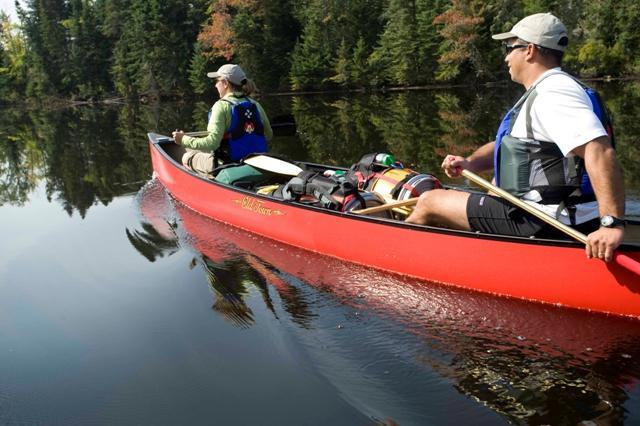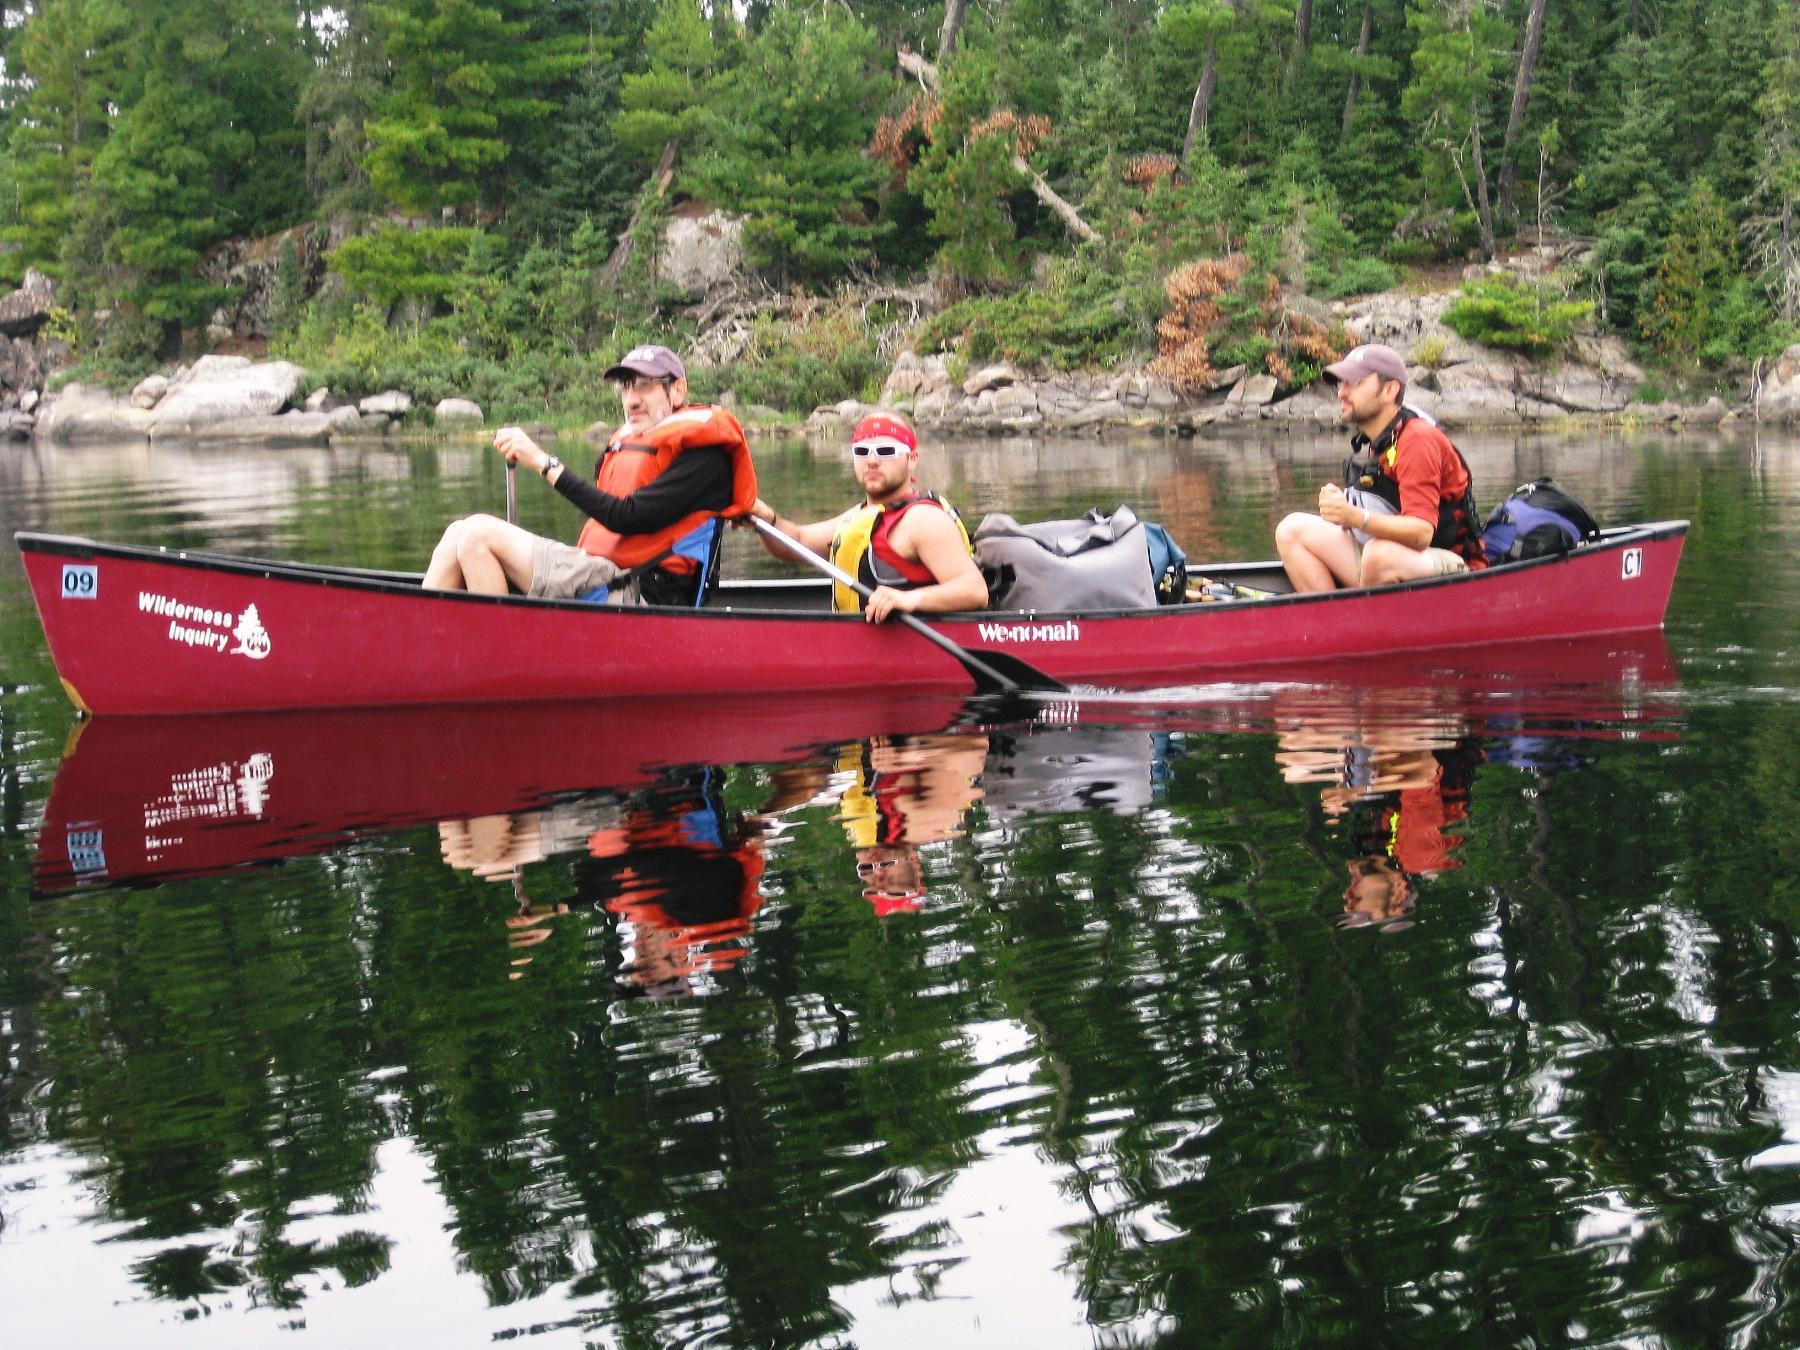The first image is the image on the left, the second image is the image on the right. Evaluate the accuracy of this statement regarding the images: "There are no more than 4 canoeists.". Is it true? Answer yes or no. No. The first image is the image on the left, the second image is the image on the right. Examine the images to the left and right. Is the description "One image contains at least one red canoe on water, and the other contains at least one beige canoe." accurate? Answer yes or no. No. 